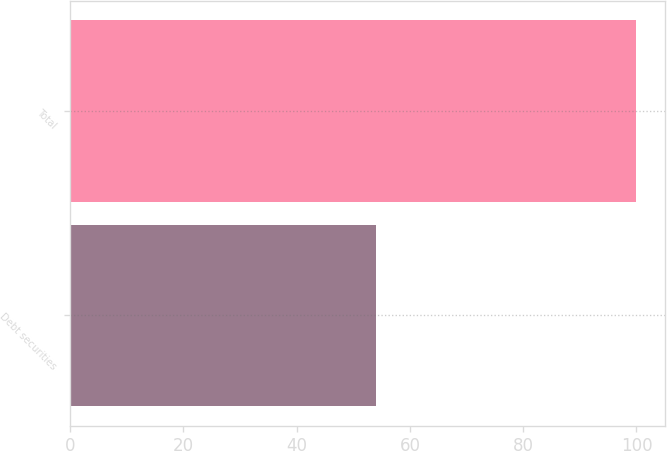<chart> <loc_0><loc_0><loc_500><loc_500><bar_chart><fcel>Debt securities<fcel>Total<nl><fcel>54<fcel>100<nl></chart> 